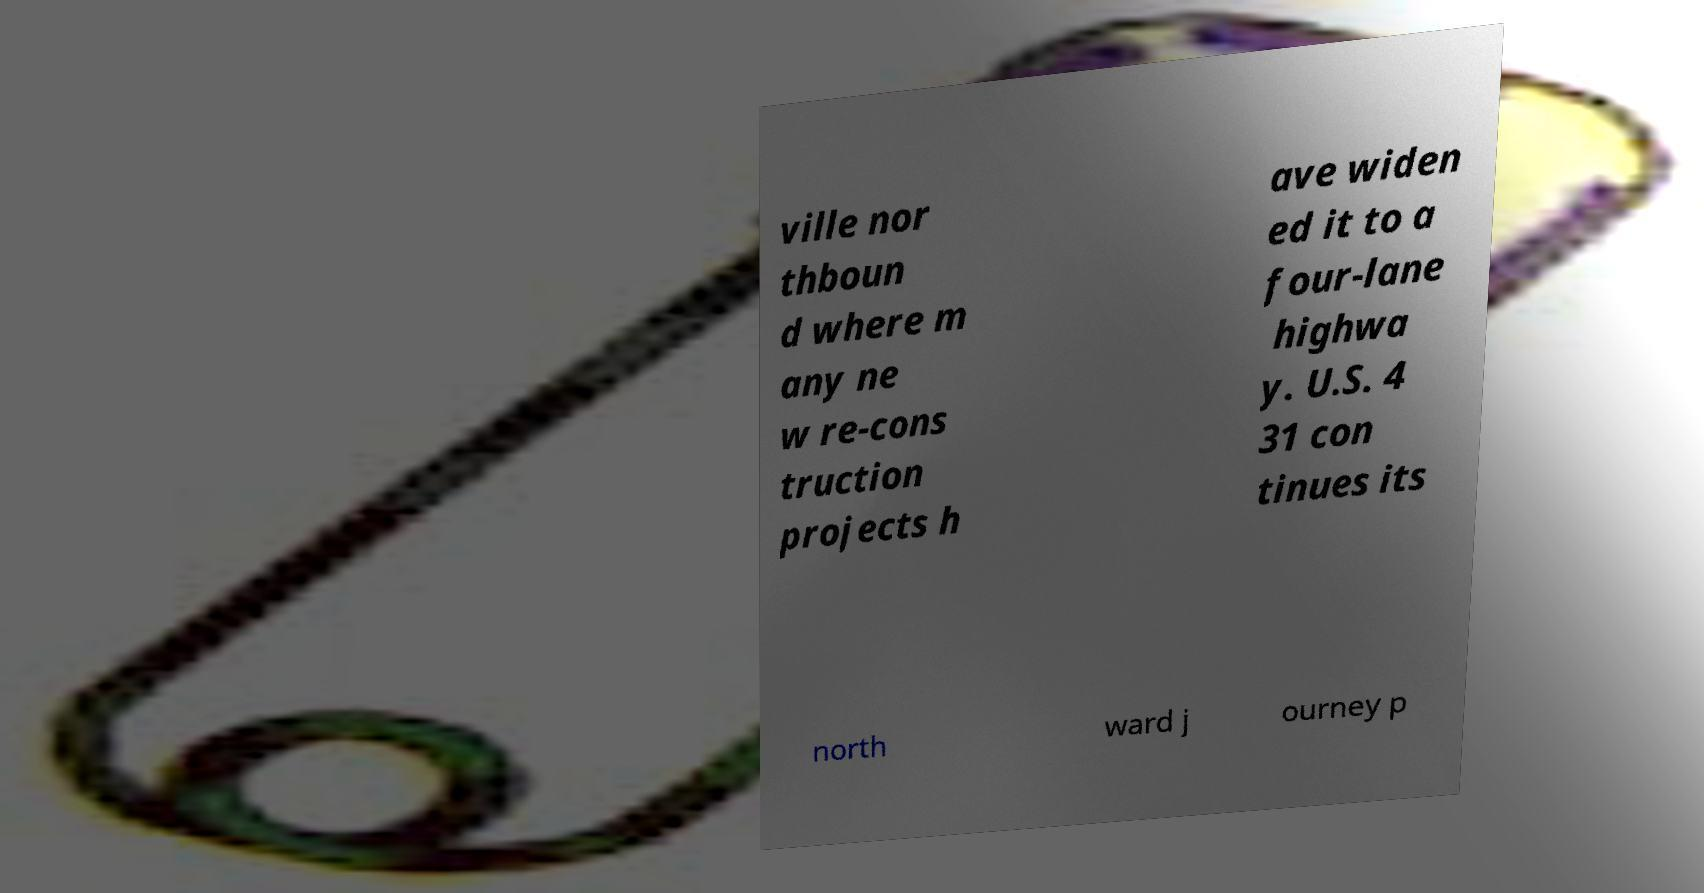Please read and relay the text visible in this image. What does it say? ville nor thboun d where m any ne w re-cons truction projects h ave widen ed it to a four-lane highwa y. U.S. 4 31 con tinues its north ward j ourney p 